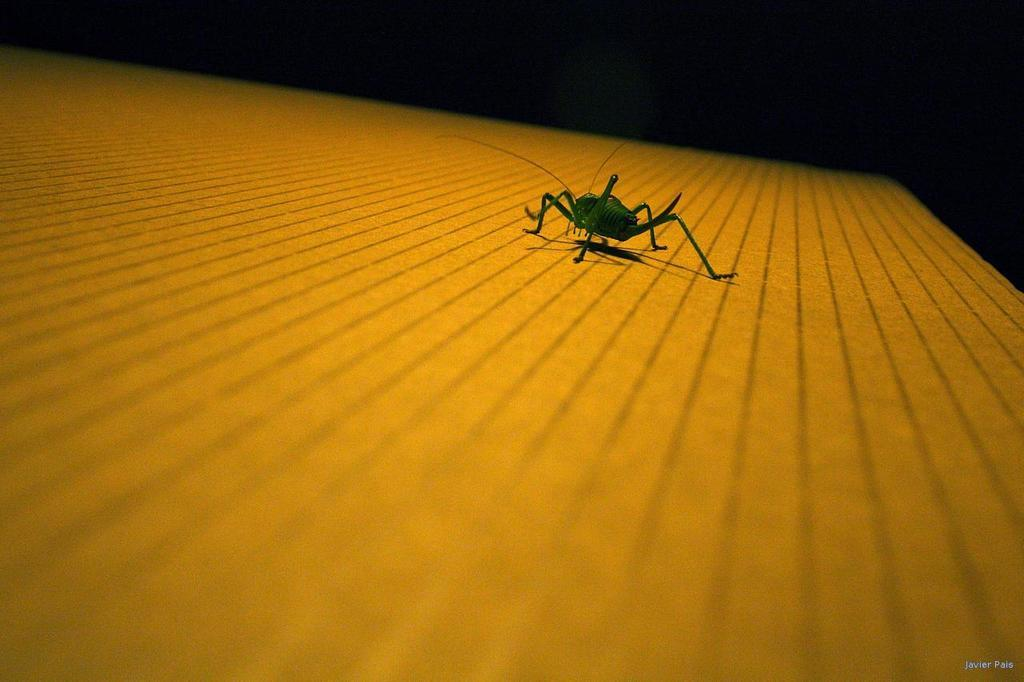What type of insect is in the image? There is a green color insect in the image. What is the insect resting on? The insect is on a yellow color surface. What color is the background of the image? The background of the image is black. Can you see any waves in the image? There are no waves present in the image; it features a green insect on a yellow surface with a black background. 